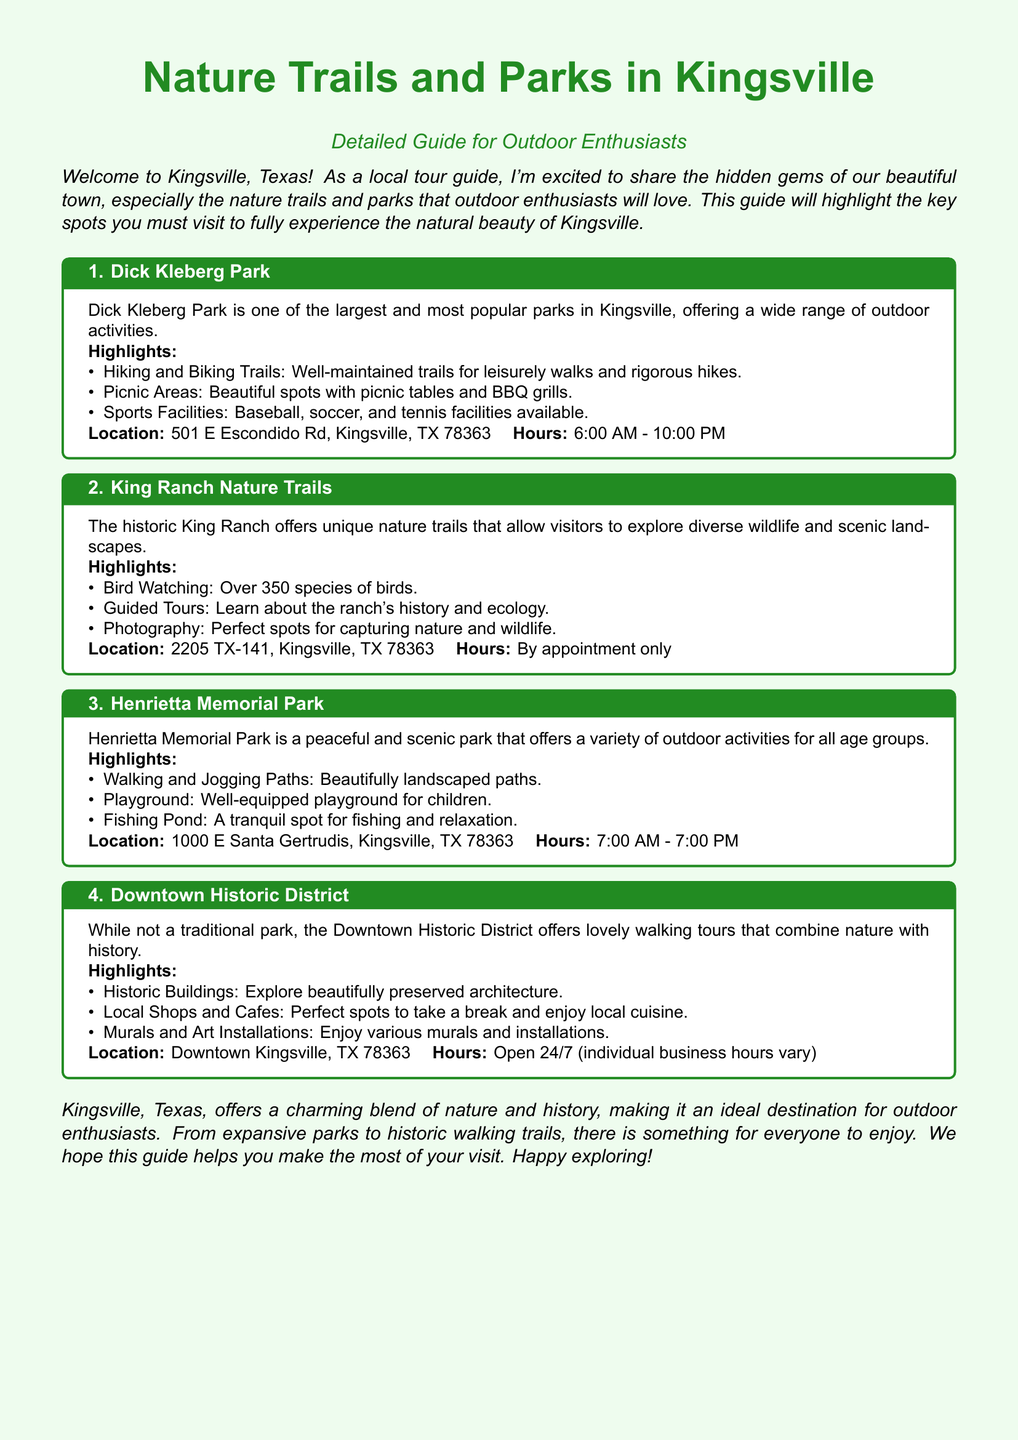What are the hours of Dick Kleberg Park? The hours for Dick Kleberg Park are listed in the document, indicating it is open from 6:00 AM to 10:00 PM.
Answer: 6:00 AM - 10:00 PM How many species of birds can be found at King Ranch? The document mentions that over 350 species of birds can be observed at King Ranch.
Answer: Over 350 species What activities does Henrietta Memorial Park offer? The document provides specific outdoor activities available at Henrietta Memorial Park including walking, jogging, and fishing.
Answer: Walking, jogging, fishing What is the location of the Downtown Historic District? The location of the Downtown Historic District is stated as Downtown Kingsville, TX 78363 in the document.
Answer: Downtown Kingsville, TX 78363 Which park has a playground? The document highlights that Henrietta Memorial Park includes a well-equipped playground for children.
Answer: Henrietta Memorial Park What is the primary purpose of this guide? The document details that the guide aims to share hidden gems and highlight nature trails and parks for outdoor enthusiasts.
Answer: Share hidden gems for outdoor enthusiasts What type of tours are available at King Ranch? The document specifies that guided tours are available to learn about the ranch's history and ecology.
Answer: Guided tours 